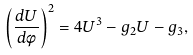<formula> <loc_0><loc_0><loc_500><loc_500>\left ( \frac { d U } { d \phi } \right ) ^ { 2 } = 4 U ^ { 3 } - g _ { 2 } U - g _ { 3 } ,</formula> 